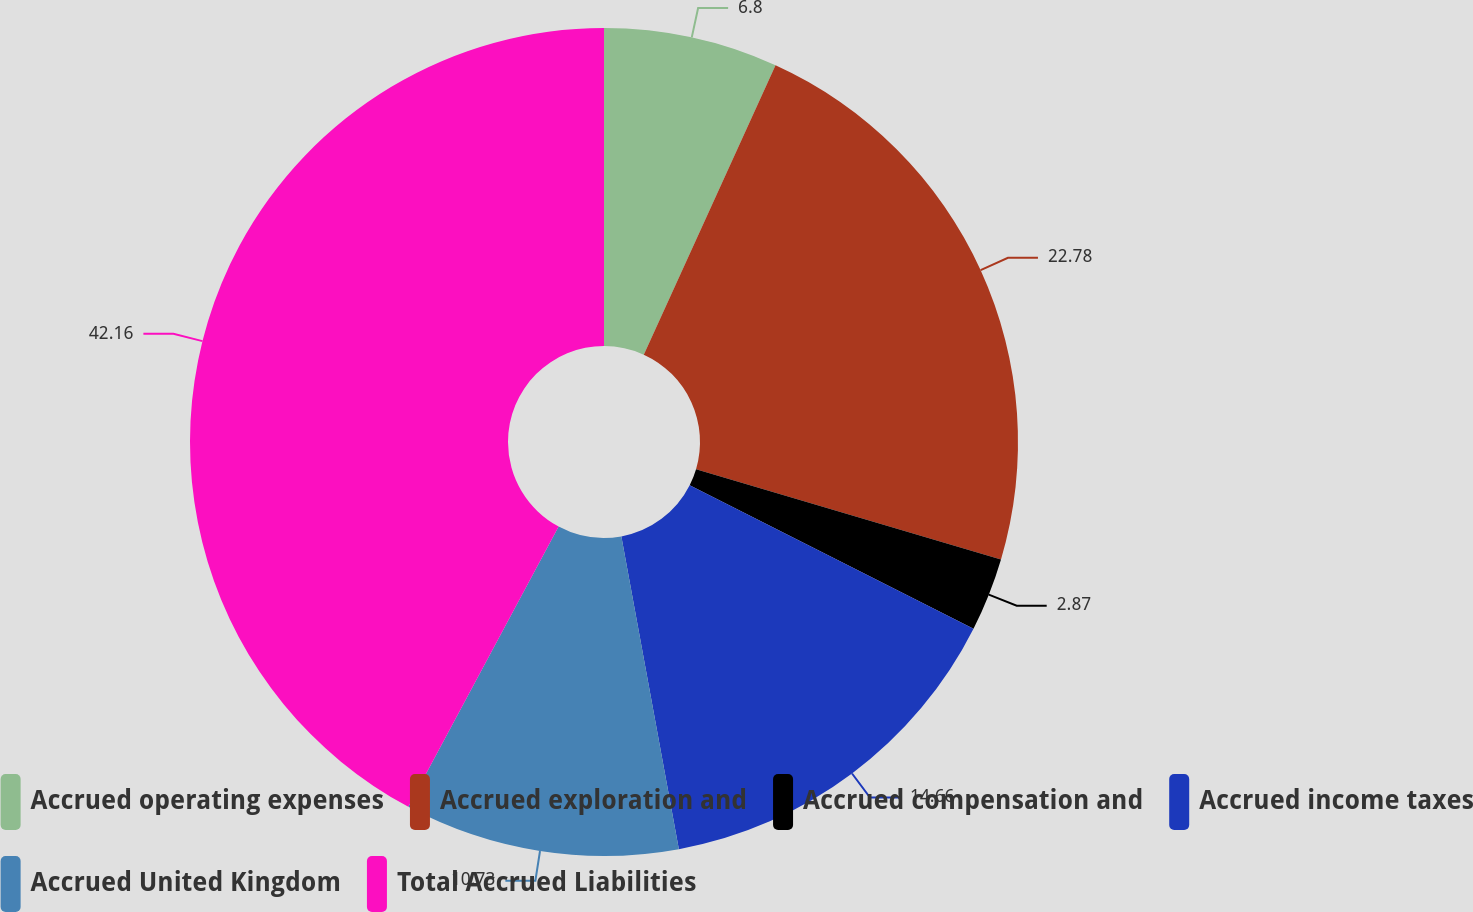Convert chart. <chart><loc_0><loc_0><loc_500><loc_500><pie_chart><fcel>Accrued operating expenses<fcel>Accrued exploration and<fcel>Accrued compensation and<fcel>Accrued income taxes<fcel>Accrued United Kingdom<fcel>Total Accrued Liabilities<nl><fcel>6.8%<fcel>22.78%<fcel>2.87%<fcel>14.66%<fcel>10.73%<fcel>42.17%<nl></chart> 